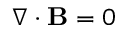<formula> <loc_0><loc_0><loc_500><loc_500>\nabla \cdot B = 0</formula> 